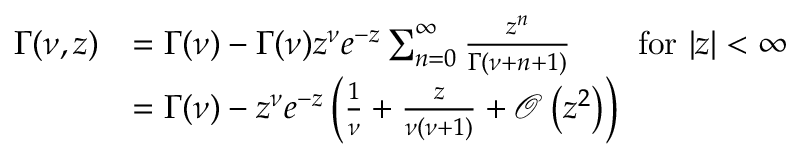Convert formula to latex. <formula><loc_0><loc_0><loc_500><loc_500>\begin{array} { r l } { \Gamma ( \nu , z ) } & { = \Gamma ( \nu ) - \Gamma ( \nu ) z ^ { \nu } e ^ { - z } \sum _ { n = 0 } ^ { \infty } \frac { z ^ { n } } { \Gamma ( \nu + n + 1 ) } \quad f o r \ | z | < \infty } \\ & { = \Gamma ( \nu ) - z ^ { \nu } e ^ { - z } \left ( \frac { 1 } { \nu } + \frac { z } { \nu ( \nu + 1 ) } + \mathcal { O } \left ( z ^ { 2 } \right ) \right ) } \end{array}</formula> 